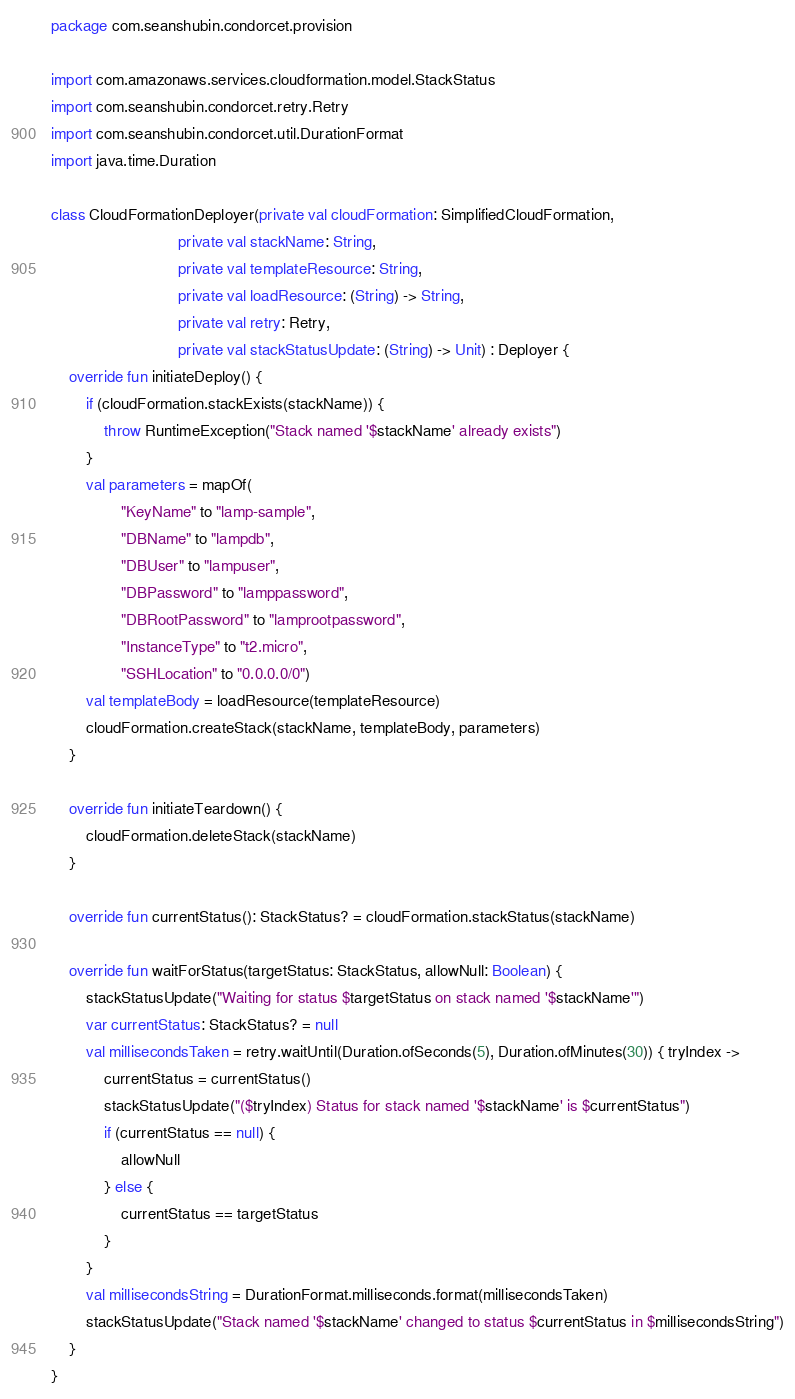Convert code to text. <code><loc_0><loc_0><loc_500><loc_500><_Kotlin_>package com.seanshubin.condorcet.provision

import com.amazonaws.services.cloudformation.model.StackStatus
import com.seanshubin.condorcet.retry.Retry
import com.seanshubin.condorcet.util.DurationFormat
import java.time.Duration

class CloudFormationDeployer(private val cloudFormation: SimplifiedCloudFormation,
                             private val stackName: String,
                             private val templateResource: String,
                             private val loadResource: (String) -> String,
                             private val retry: Retry,
                             private val stackStatusUpdate: (String) -> Unit) : Deployer {
    override fun initiateDeploy() {
        if (cloudFormation.stackExists(stackName)) {
            throw RuntimeException("Stack named '$stackName' already exists")
        }
        val parameters = mapOf(
                "KeyName" to "lamp-sample",
                "DBName" to "lampdb",
                "DBUser" to "lampuser",
                "DBPassword" to "lamppassword",
                "DBRootPassword" to "lamprootpassword",
                "InstanceType" to "t2.micro",
                "SSHLocation" to "0.0.0.0/0")
        val templateBody = loadResource(templateResource)
        cloudFormation.createStack(stackName, templateBody, parameters)
    }

    override fun initiateTeardown() {
        cloudFormation.deleteStack(stackName)
    }

    override fun currentStatus(): StackStatus? = cloudFormation.stackStatus(stackName)

    override fun waitForStatus(targetStatus: StackStatus, allowNull: Boolean) {
        stackStatusUpdate("Waiting for status $targetStatus on stack named '$stackName'")
        var currentStatus: StackStatus? = null
        val millisecondsTaken = retry.waitUntil(Duration.ofSeconds(5), Duration.ofMinutes(30)) { tryIndex ->
            currentStatus = currentStatus()
            stackStatusUpdate("($tryIndex) Status for stack named '$stackName' is $currentStatus")
            if (currentStatus == null) {
                allowNull
            } else {
                currentStatus == targetStatus
            }
        }
        val millisecondsString = DurationFormat.milliseconds.format(millisecondsTaken)
        stackStatusUpdate("Stack named '$stackName' changed to status $currentStatus in $millisecondsString")
    }
}
</code> 